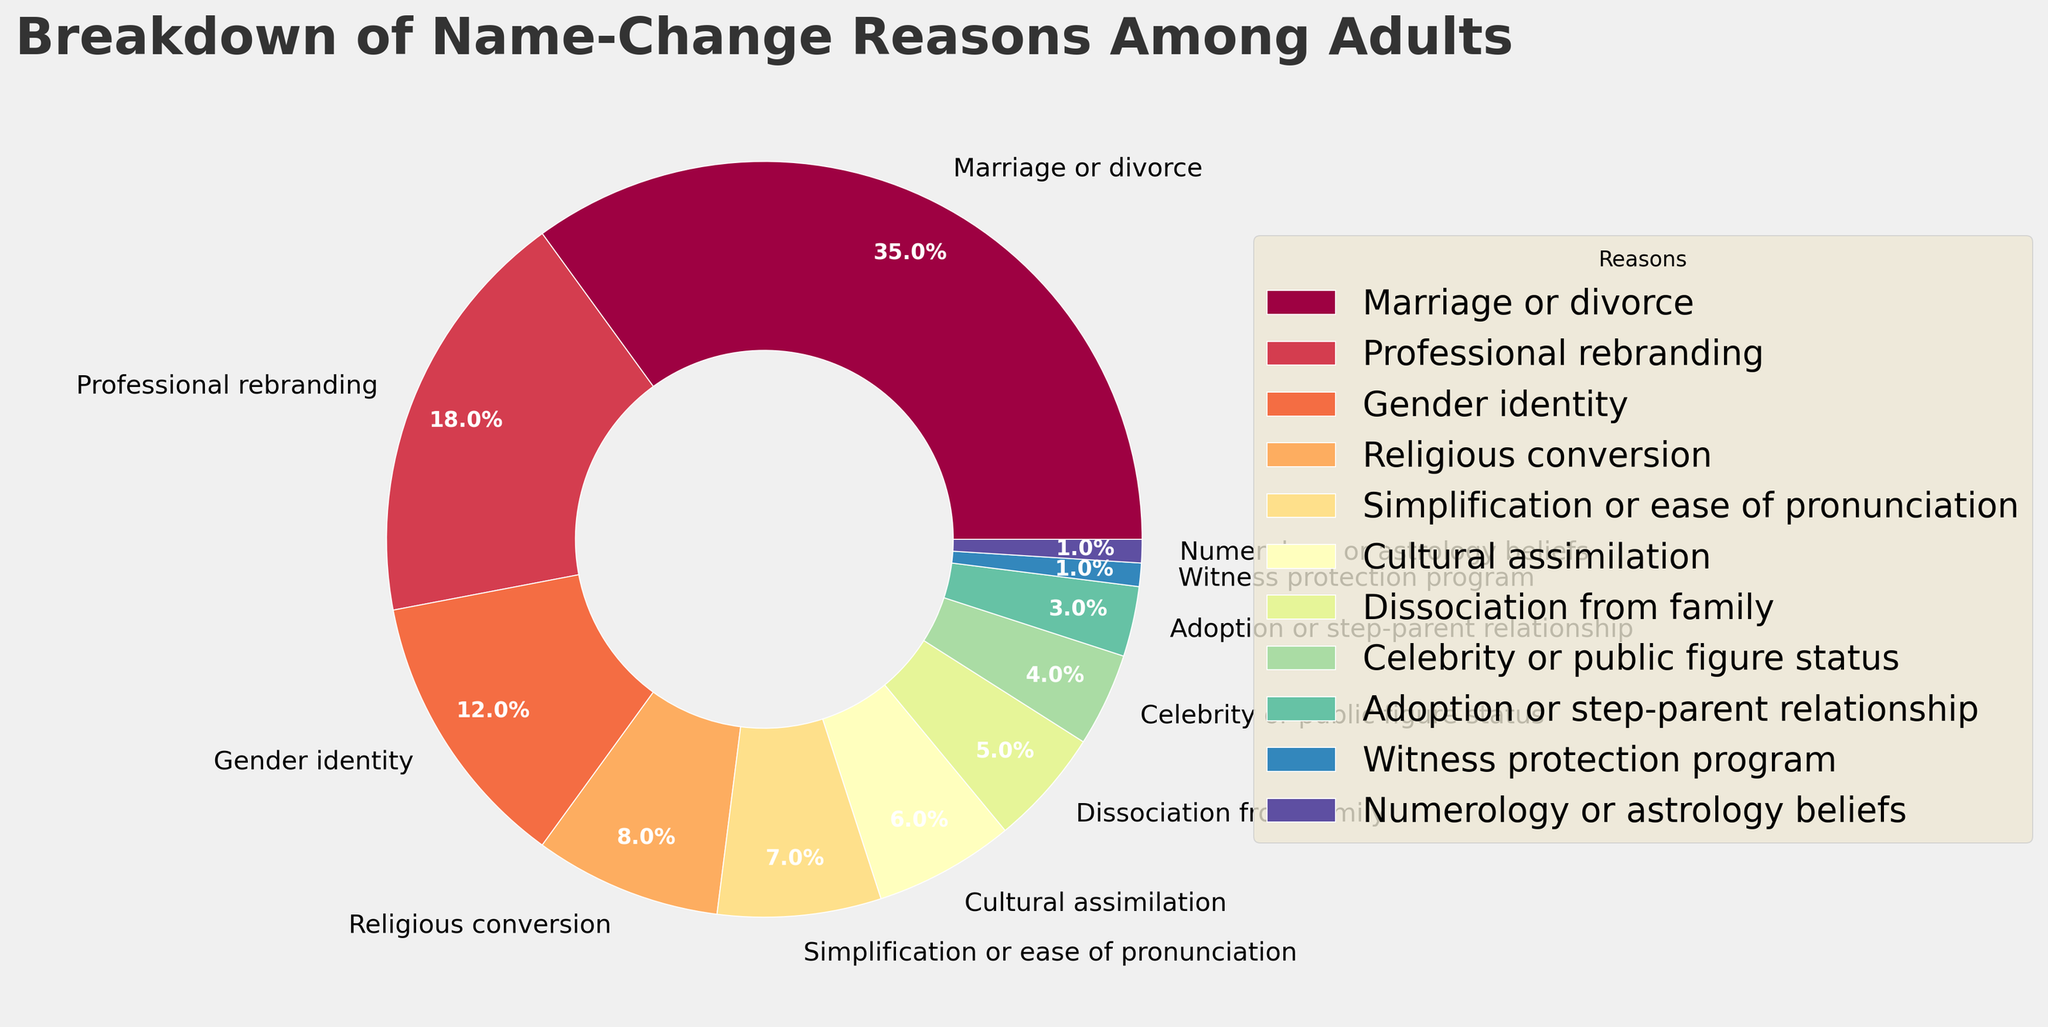Which reason for name changes has the highest percentage? The figure shows that "Marriage or divorce" has the largest wedge in the pie chart. This implies it has the highest percentage.
Answer: Marriage or divorce Which reason for name changes has the lowest percentage? The figure shows that "Witness protection program" and "Numerology or astrology beliefs" have the smallest wedges in the pie chart. This implies they have the lowest percentage.
Answer: Witness protection program and Numerology or astrology beliefs What is the combined percentage for name changes due to Gender identity, Religious conversion, and Simplification or ease of pronunciation? To find the combined percentage, sum the individual percentages for Gender identity (12), Religious conversion (8), and Simplification or ease of pronunciation (7). 12 + 8 + 7 = 27
Answer: 27 How many reasons for name changes have a percentage of 10% or higher? The figure shows the percentages for each reason. Reasons that have percentages 10% or higher are "Marriage or divorce" (35%), "Professional rebranding" (18%), and "Gender identity" (12%). Count these categories.
Answer: 3 How does the percentage for Professional rebranding compare to Religious conversion? The figure presents the percentage for Professional rebranding as 18% and for Religious conversion as 8%. Comparing these values shows that Professional rebranding has a higher percentage.
Answer: Professional rebranding is higher What is the percentage difference between Cultural assimilation and Dissociation from family? The percentage for Cultural assimilation is 6% and for Dissociation from family is 5%. To find the difference, subtract 5 from 6. 6 - 5 = 1
Answer: 1 What is the sum of percentages for the three smallest reasons for name changes? The three smallest reasons are Adoption or step-parent relationship (3%), Witness protection program (1%), and Numerology or astrology beliefs (1%). Sum these percentages: 3 + 1 + 1 = 5
Answer: 5 Which color is used for the wedge representing Marriage or divorce? The visual representation shows that each reason for name change is assigned a unique color. Identify the color used for "Marriage or divorce" by examining the corresponding wedge in the pie chart.
Answer: Identify visually (depends on color scheme) What percentage of name changes is due to Gender identity, Cultural assimilation, and Dissociation from family combined? To find the combined percentage, sum Gender identity (12%), Cultural assimilation (6%), and Dissociation from family (5%). 12 + 6 + 5 = 23
Answer: 23 Are there more percentage points for name changes due to Marriage or divorce than for all reasons combined below 5%? The percentage for Marriage or divorce is 35%. The reasons below 5% are Adoption or step-parent relationship (3%), Witness protection program (1%), Numerology or astrology beliefs (1%). Summing these gives 3 + 1 + 1 = 5. Compare 35 with 5.
Answer: Yes 